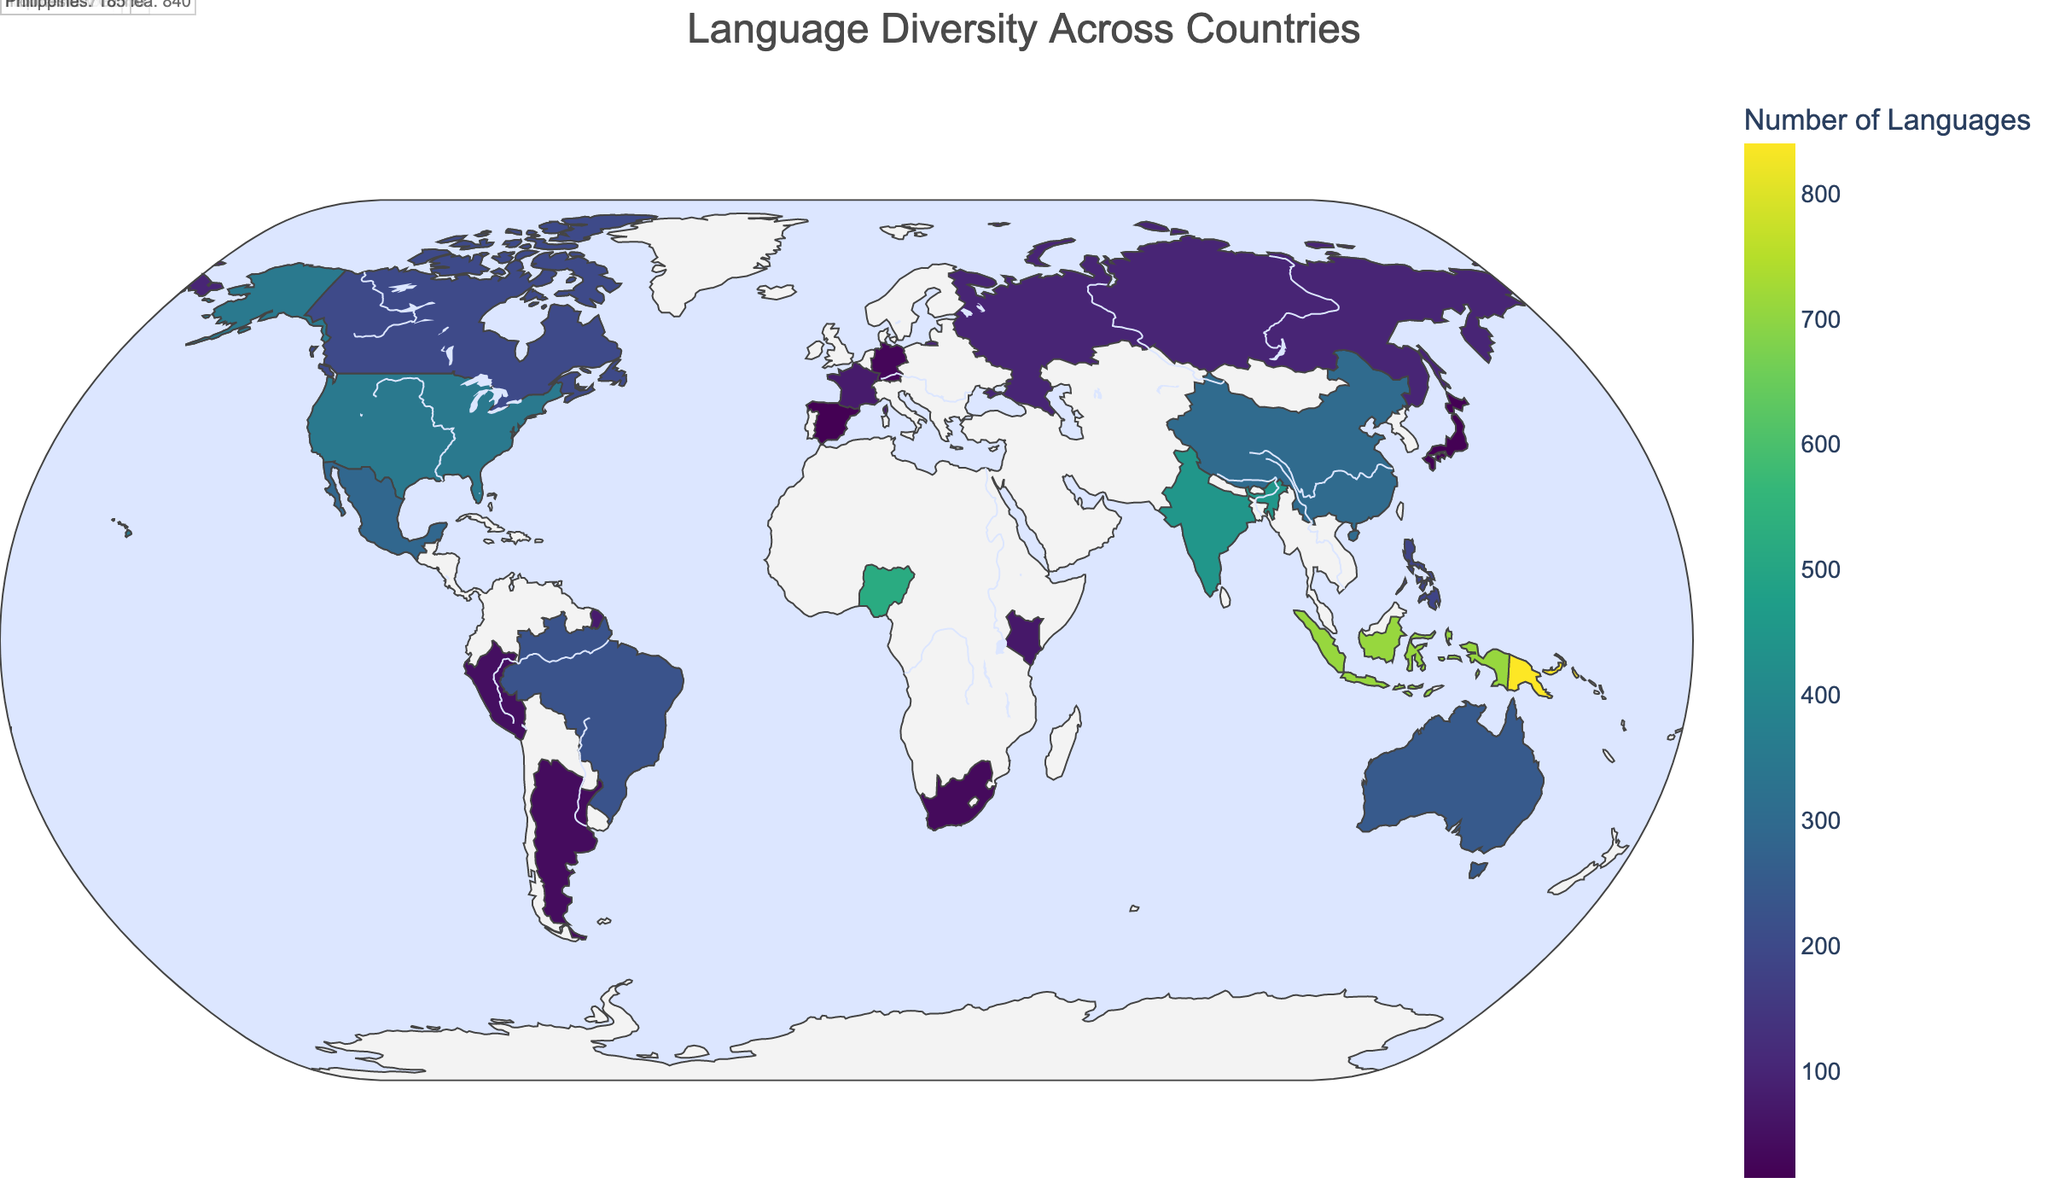What's the title of the map? The title is displayed at the top of the map and gives a concise description of the map's content.
Answer: "Language Diversity Across Countries" How many languages are spoken in Nigeria? The number of languages spoken in each country is color-coded and labeled on the map. You can find Nigeria and see its label.
Answer: 520 Which country in Eastern Europe has 100 spoken languages? Eastern Europe is part of the map, and by locating the countries there, you can see which one has 100 languages labeled.
Answer: Russia How many more languages are spoken in India compared to Japan? Locate both India and Japan on the map and note the number of languages spoken in each. Subtract the number for Japan from the number for India to get the answer.
Answer: 432 Which region in Africa has the country with the highest number of spoken languages? By examining the countries in Africa and their corresponding regions along with the number of languages spoken, you can determine which region stands out. Nigeria in West Africa has the highest count.
Answer: West Africa What is the difference in the number of languages spoken between Australia and Papua New Guinea? Find Australia and Papua New Guinea on the map and note their respective number of languages spoken. Subtract the number for Australia from the number for Papua New Guinea to get the difference.
Answer: 590 Which country in Western Europe has the fewest languages spoken? By analyzing the Western European countries on the map and comparing their language counts, the one with the least number will be the answer.
Answer: Germany What is the average number of languages spoken in Southeast Asia? Identify the countries in Southeast Asia (Indonesia and Philippines) and their language counts. Add these numbers and divide by the total number of countries in the region. (710 + 185) / 2 = 447.5
Answer: 447.5 Is there any country in South America with fewer than 50 languages spoken? Review the countries in South America and compare their language counts to see if any have fewer than 50 spoken languages. Both Peru and Argentina meet this criterion.
Answer: Yes Which country has the highest number of spoken languages globally? Compare the language counts for all countries on the map to identify the one with the highest number.
Answer: Papua New Guinea 